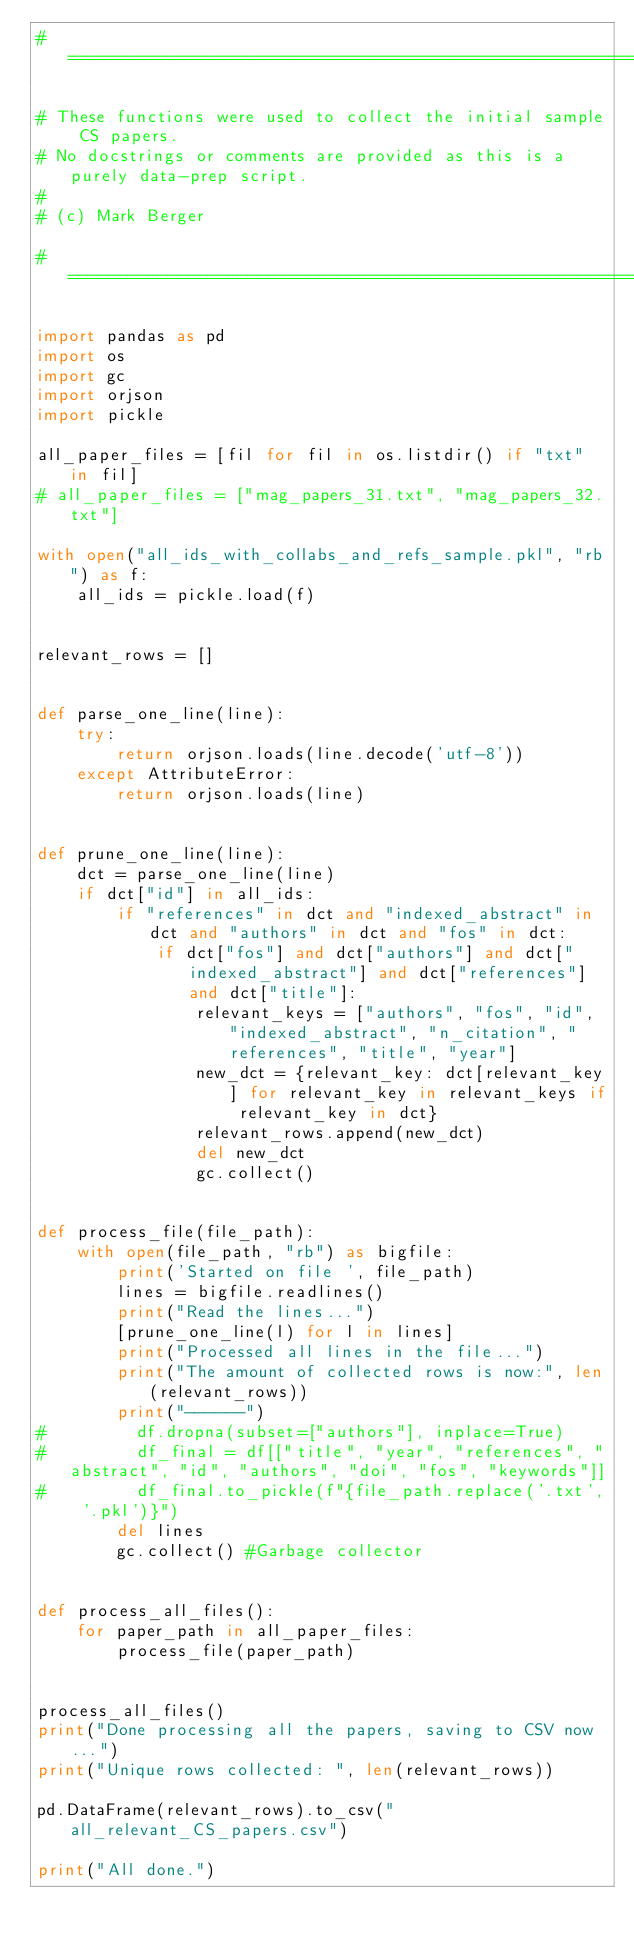Convert code to text. <code><loc_0><loc_0><loc_500><loc_500><_Python_># ============================================================================

# These functions were used to collect the initial sample CS papers.
# No docstrings or comments are provided as this is a purely data-prep script.
#
# (c) Mark Berger

# ============================================================================

import pandas as pd
import os
import gc
import orjson
import pickle

all_paper_files = [fil for fil in os.listdir() if "txt" in fil]
# all_paper_files = ["mag_papers_31.txt", "mag_papers_32.txt"]

with open("all_ids_with_collabs_and_refs_sample.pkl", "rb") as f:
    all_ids = pickle.load(f)


relevant_rows = []


def parse_one_line(line):
    try:
        return orjson.loads(line.decode('utf-8'))
    except AttributeError:
        return orjson.loads(line)


def prune_one_line(line):
    dct = parse_one_line(line)
    if dct["id"] in all_ids:
        if "references" in dct and "indexed_abstract" in dct and "authors" in dct and "fos" in dct:
            if dct["fos"] and dct["authors"] and dct["indexed_abstract"] and dct["references"] and dct["title"]:
                relevant_keys = ["authors", "fos", "id", "indexed_abstract", "n_citation", "references", "title", "year"]
                new_dct = {relevant_key: dct[relevant_key] for relevant_key in relevant_keys if relevant_key in dct}
                relevant_rows.append(new_dct)
                del new_dct
                gc.collect()


def process_file(file_path):
    with open(file_path, "rb") as bigfile:
        print('Started on file ', file_path)
        lines = bigfile.readlines()
        print("Read the lines...")
        [prune_one_line(l) for l in lines]
        print("Processed all lines in the file...")
        print("The amount of collected rows is now:", len(relevant_rows))
        print("------")
#         df.dropna(subset=["authors"], inplace=True)
#         df_final = df[["title", "year", "references", "abstract", "id", "authors", "doi", "fos", "keywords"]]
#         df_final.to_pickle(f"{file_path.replace('.txt', '.pkl')}")
        del lines
        gc.collect() #Garbage collector


def process_all_files():
    for paper_path in all_paper_files:
        process_file(paper_path)


process_all_files()
print("Done processing all the papers, saving to CSV now...")
print("Unique rows collected: ", len(relevant_rows))

pd.DataFrame(relevant_rows).to_csv("all_relevant_CS_papers.csv")

print("All done.")</code> 